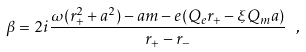Convert formula to latex. <formula><loc_0><loc_0><loc_500><loc_500>\beta = 2 i \frac { \omega ( r _ { + } ^ { 2 } + a ^ { 2 } ) - a m - e ( Q _ { e } r _ { + } - \xi Q _ { m } a ) } { r _ { + } - r _ { - } } \ ,</formula> 